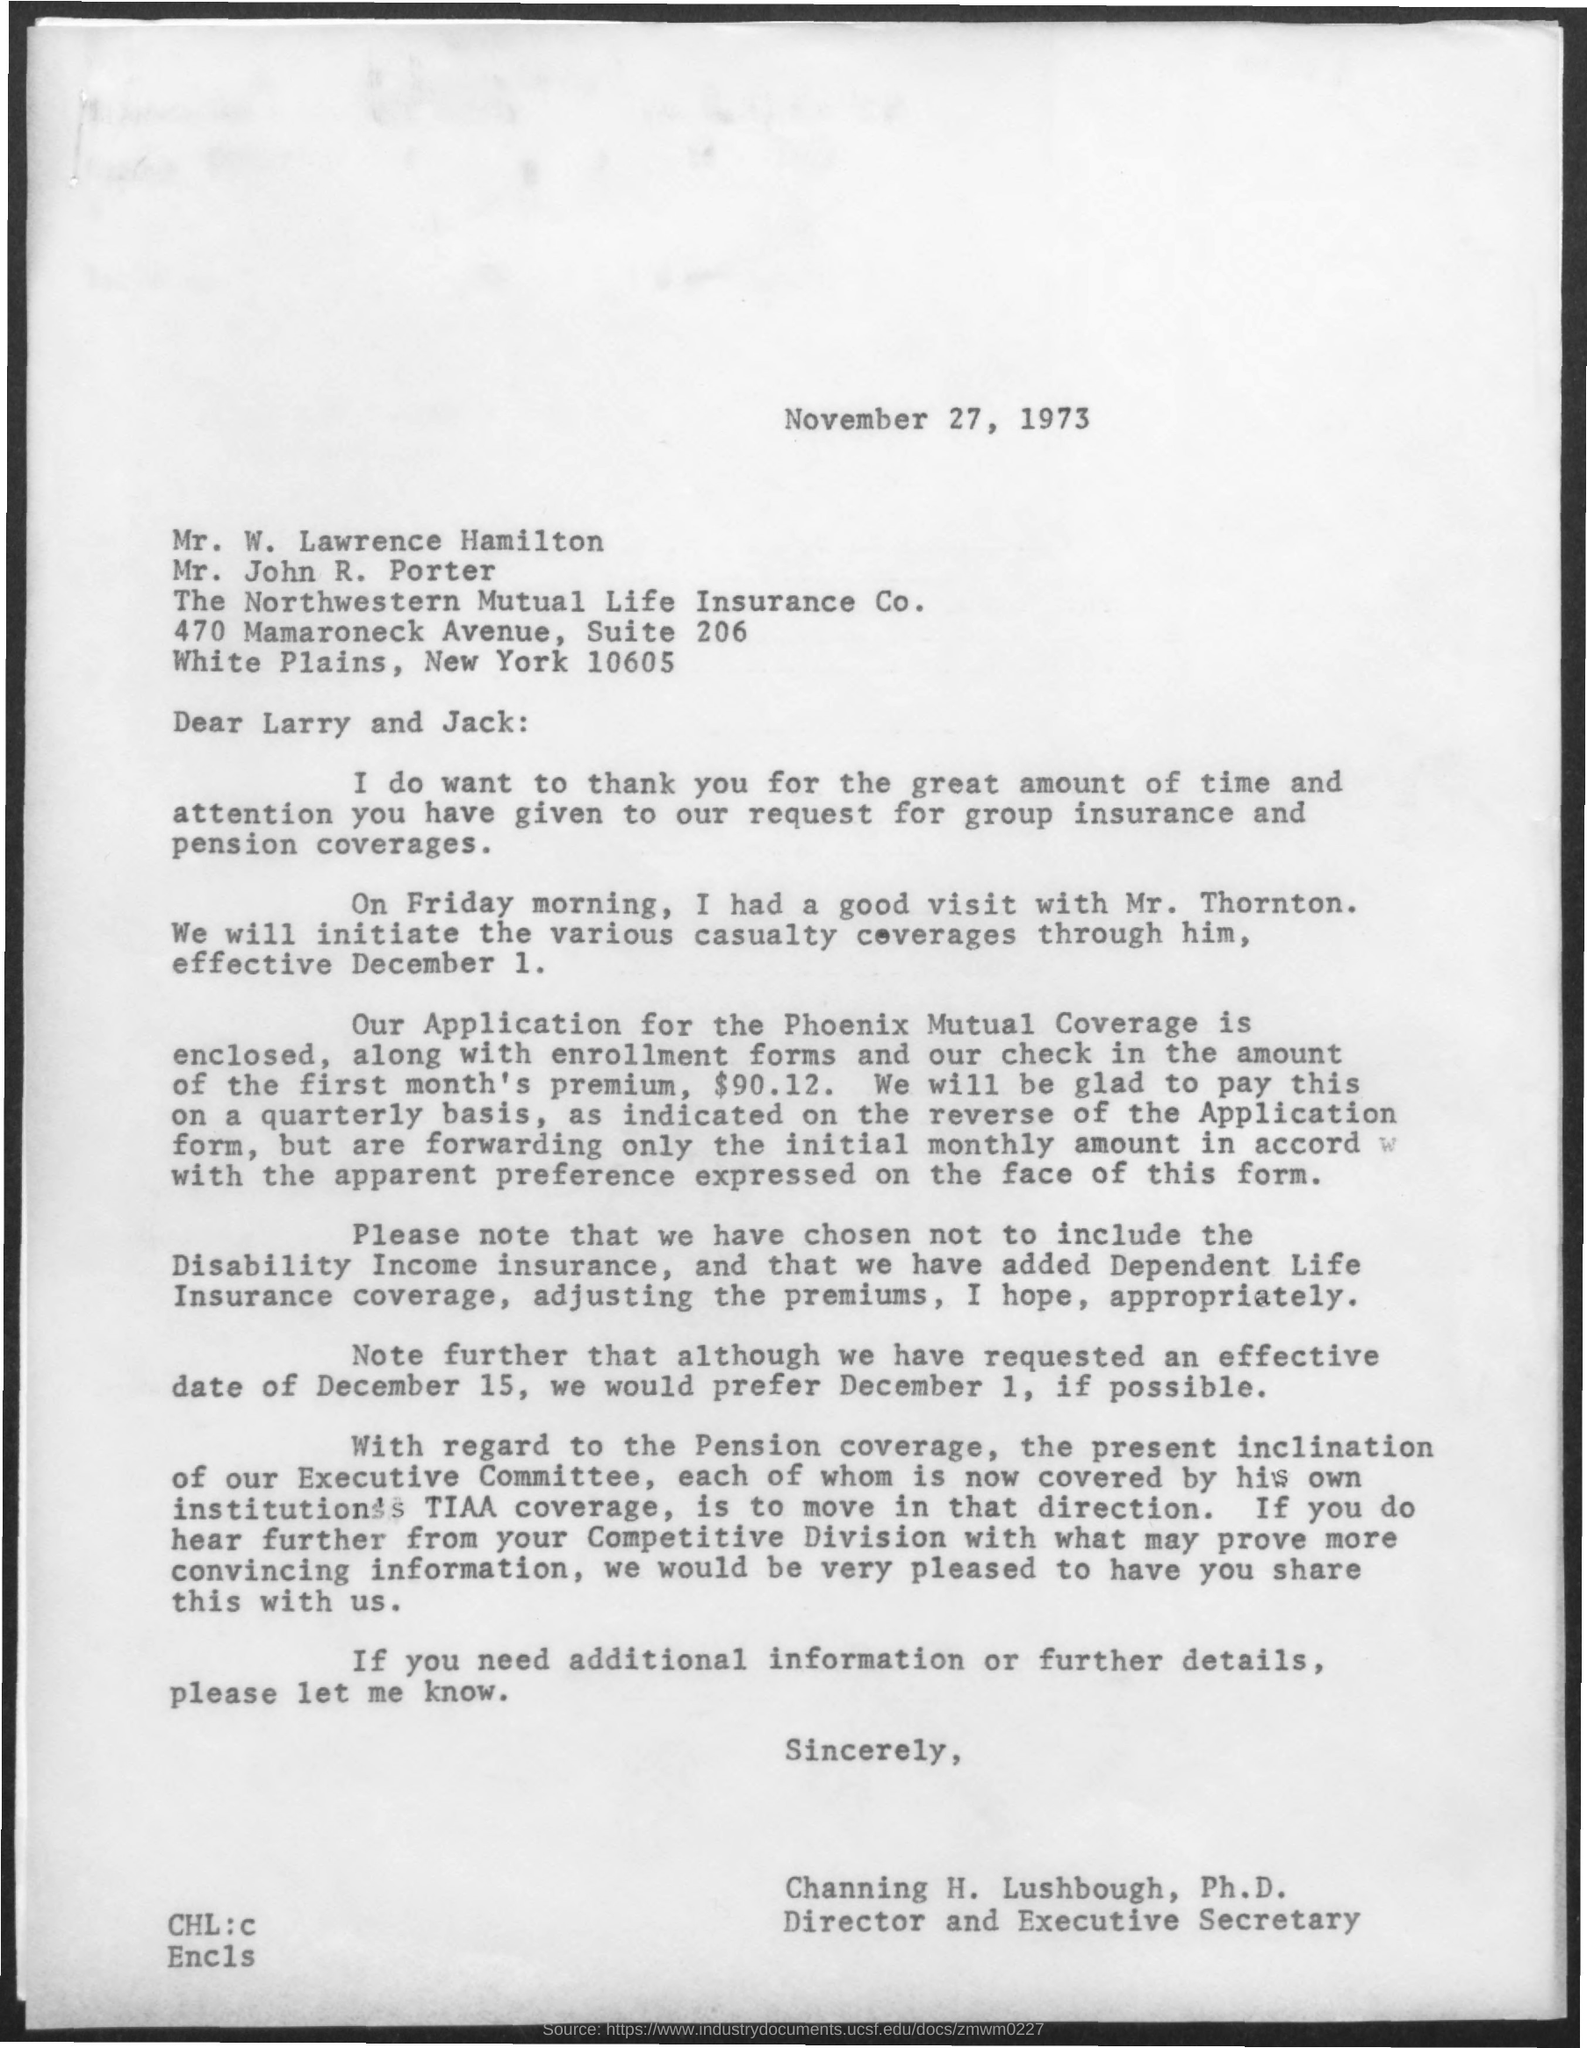Draw attention to some important aspects in this diagram. The document is dated November 27, 1973. The letter is from Channing H. Lushbough, Ph.D. The enclosed check amount is $90.12. 